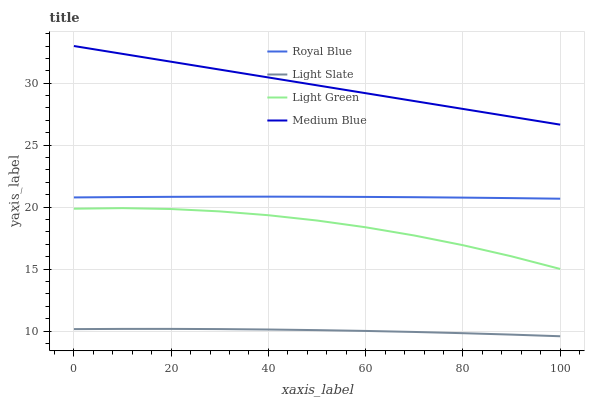Does Light Slate have the minimum area under the curve?
Answer yes or no. Yes. Does Medium Blue have the maximum area under the curve?
Answer yes or no. Yes. Does Royal Blue have the minimum area under the curve?
Answer yes or no. No. Does Royal Blue have the maximum area under the curve?
Answer yes or no. No. Is Medium Blue the smoothest?
Answer yes or no. Yes. Is Light Green the roughest?
Answer yes or no. Yes. Is Royal Blue the smoothest?
Answer yes or no. No. Is Royal Blue the roughest?
Answer yes or no. No. Does Light Slate have the lowest value?
Answer yes or no. Yes. Does Royal Blue have the lowest value?
Answer yes or no. No. Does Medium Blue have the highest value?
Answer yes or no. Yes. Does Royal Blue have the highest value?
Answer yes or no. No. Is Light Slate less than Medium Blue?
Answer yes or no. Yes. Is Medium Blue greater than Light Slate?
Answer yes or no. Yes. Does Light Slate intersect Medium Blue?
Answer yes or no. No. 